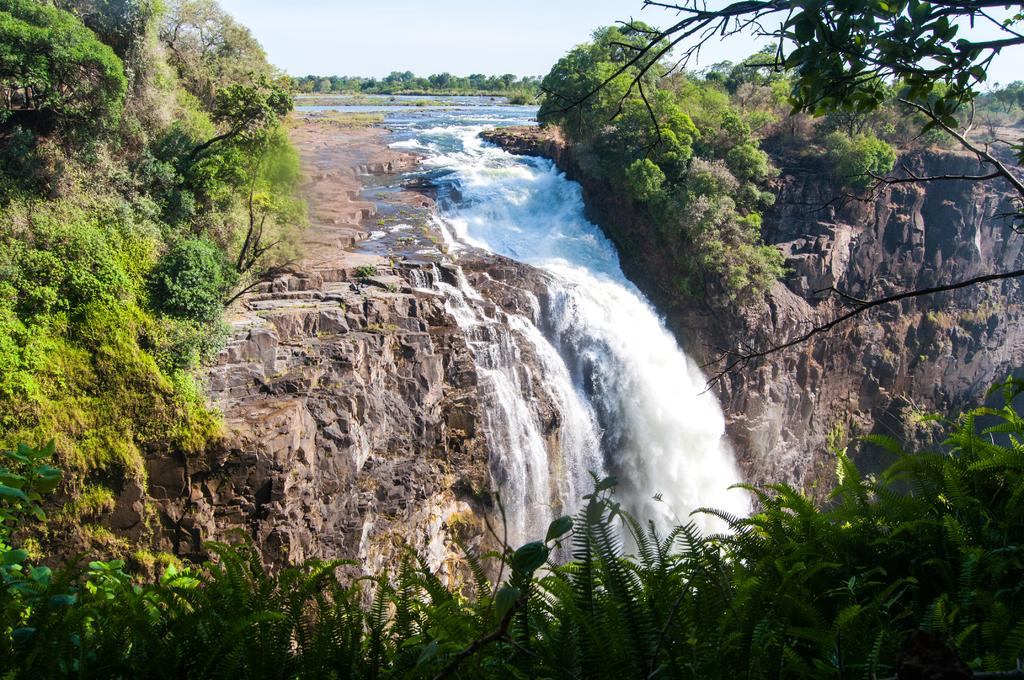What is the main feature in the center of the image? There is a waterfall in the center of the image. What can be seen surrounding the waterfall? There is greenery around the area of the image. What type of bread is being used to represent the waterfall in the image? There is no bread present in the image; it features a waterfall and greenery. What season is depicted in the image, considering the presence of winter? The provided facts do not mention any season, and there is no indication of winter in the image. 